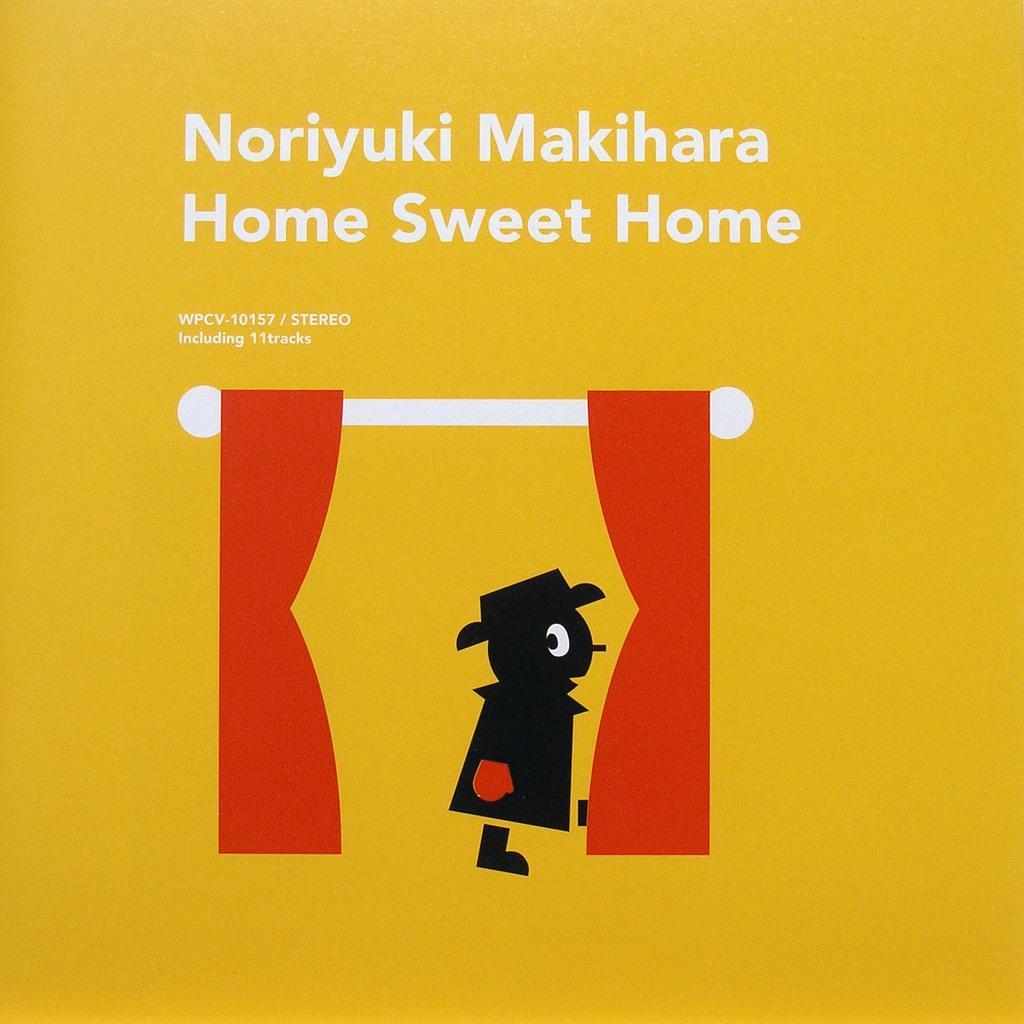How would you summarize this image in a sentence or two? I see this an animated picture and I see the white rod, red curtains and a person over here and I see few words written over here and I see the yellow background. 